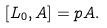Convert formula to latex. <formula><loc_0><loc_0><loc_500><loc_500>[ L _ { 0 } , A ] = p A .</formula> 